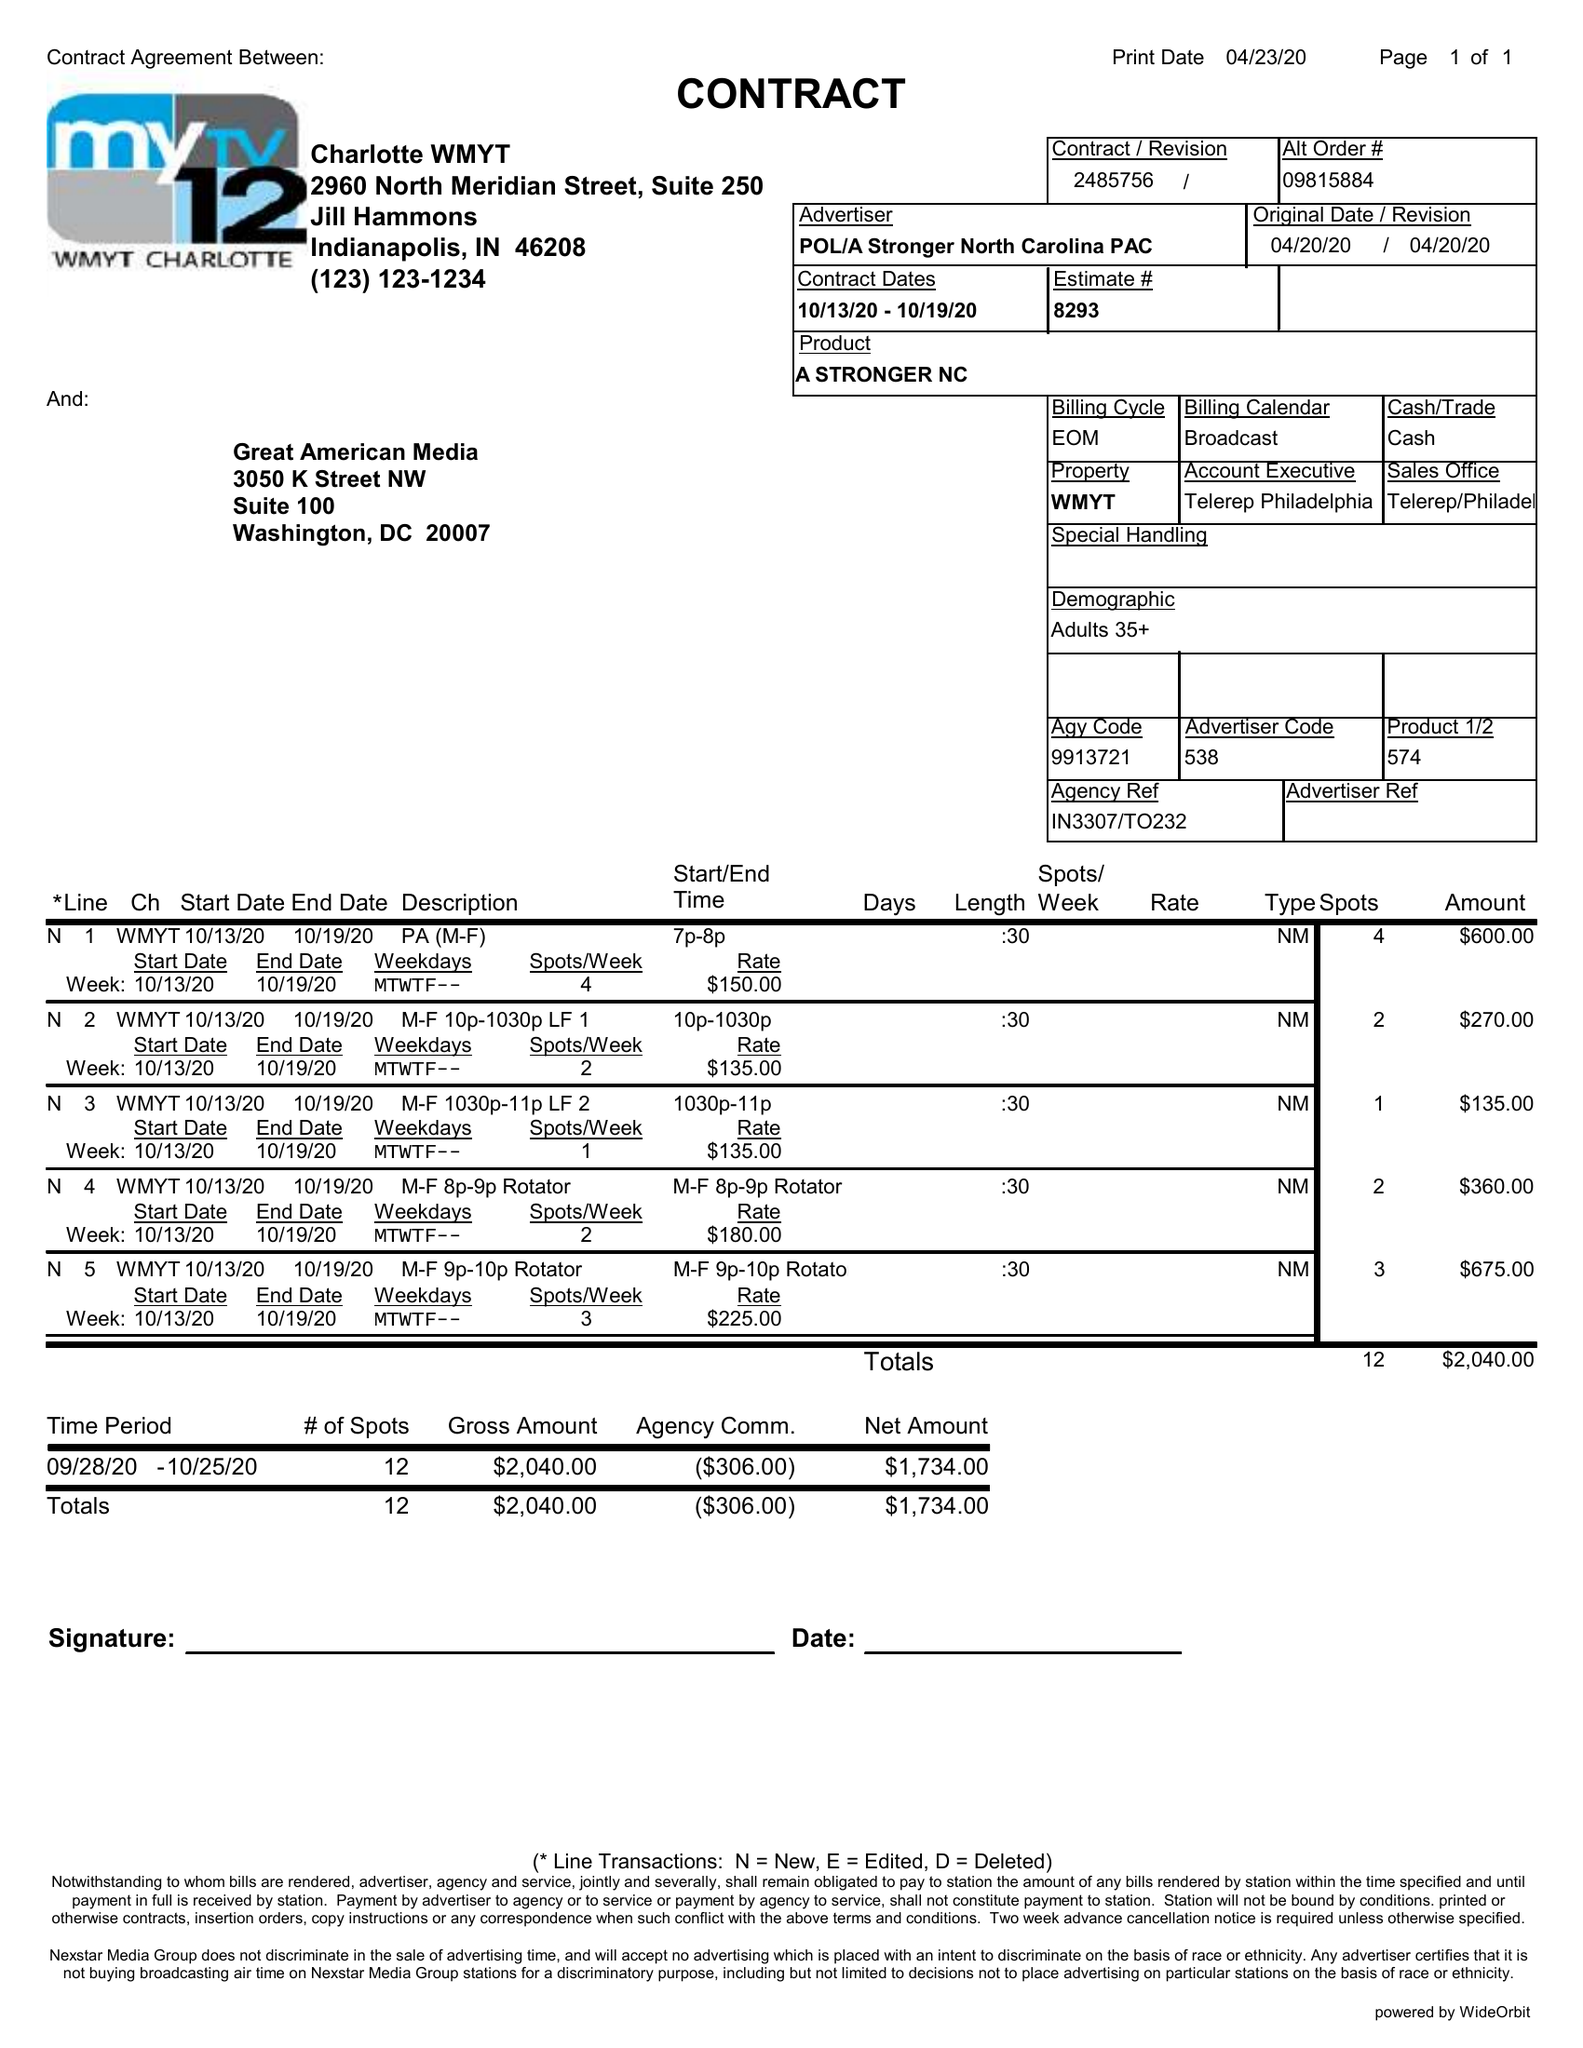What is the value for the flight_from?
Answer the question using a single word or phrase. 10/13/20 